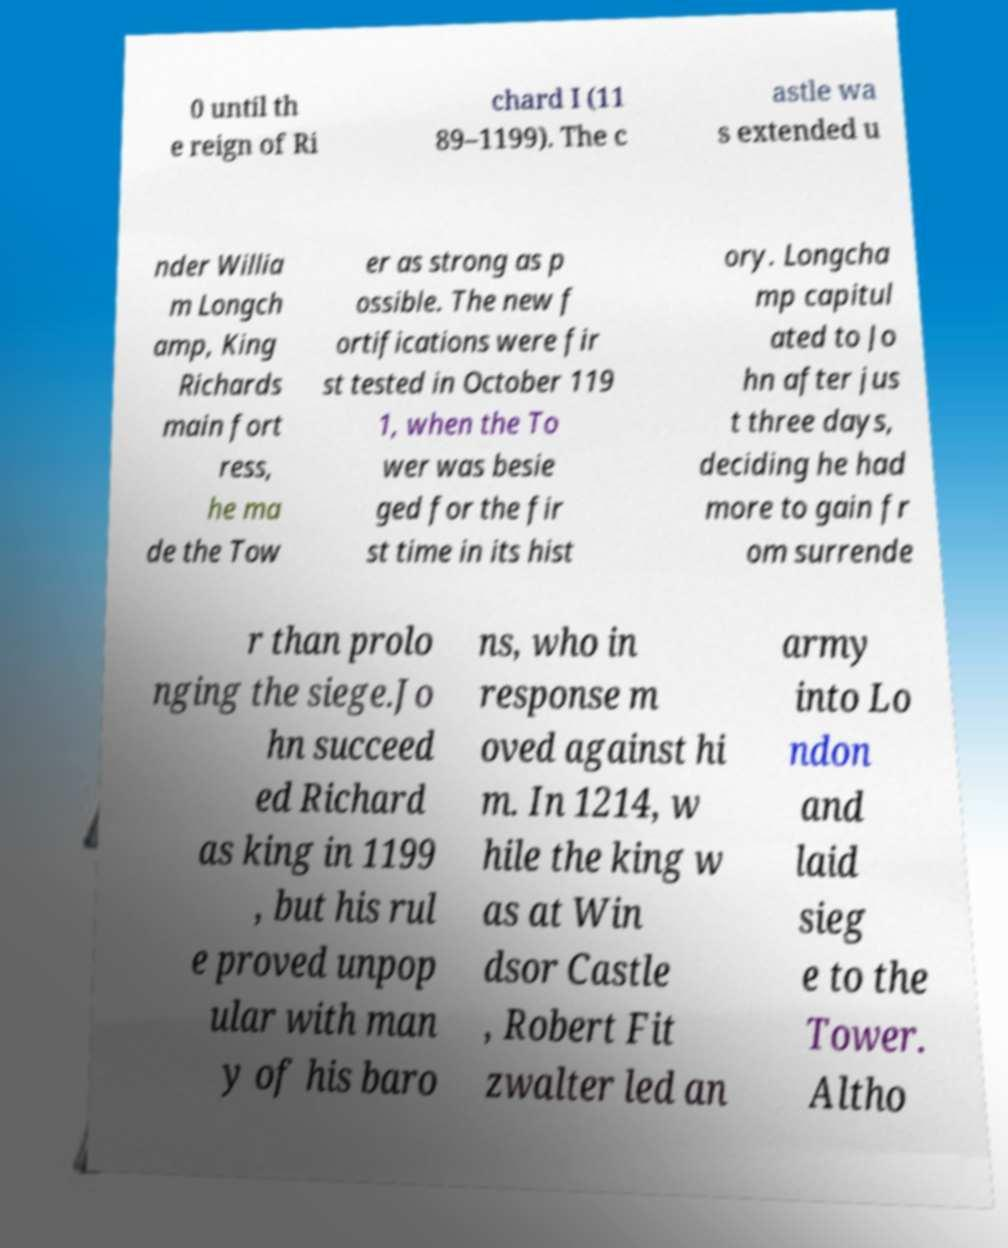Could you assist in decoding the text presented in this image and type it out clearly? 0 until th e reign of Ri chard I (11 89–1199). The c astle wa s extended u nder Willia m Longch amp, King Richards main fort ress, he ma de the Tow er as strong as p ossible. The new f ortifications were fir st tested in October 119 1, when the To wer was besie ged for the fir st time in its hist ory. Longcha mp capitul ated to Jo hn after jus t three days, deciding he had more to gain fr om surrende r than prolo nging the siege.Jo hn succeed ed Richard as king in 1199 , but his rul e proved unpop ular with man y of his baro ns, who in response m oved against hi m. In 1214, w hile the king w as at Win dsor Castle , Robert Fit zwalter led an army into Lo ndon and laid sieg e to the Tower. Altho 